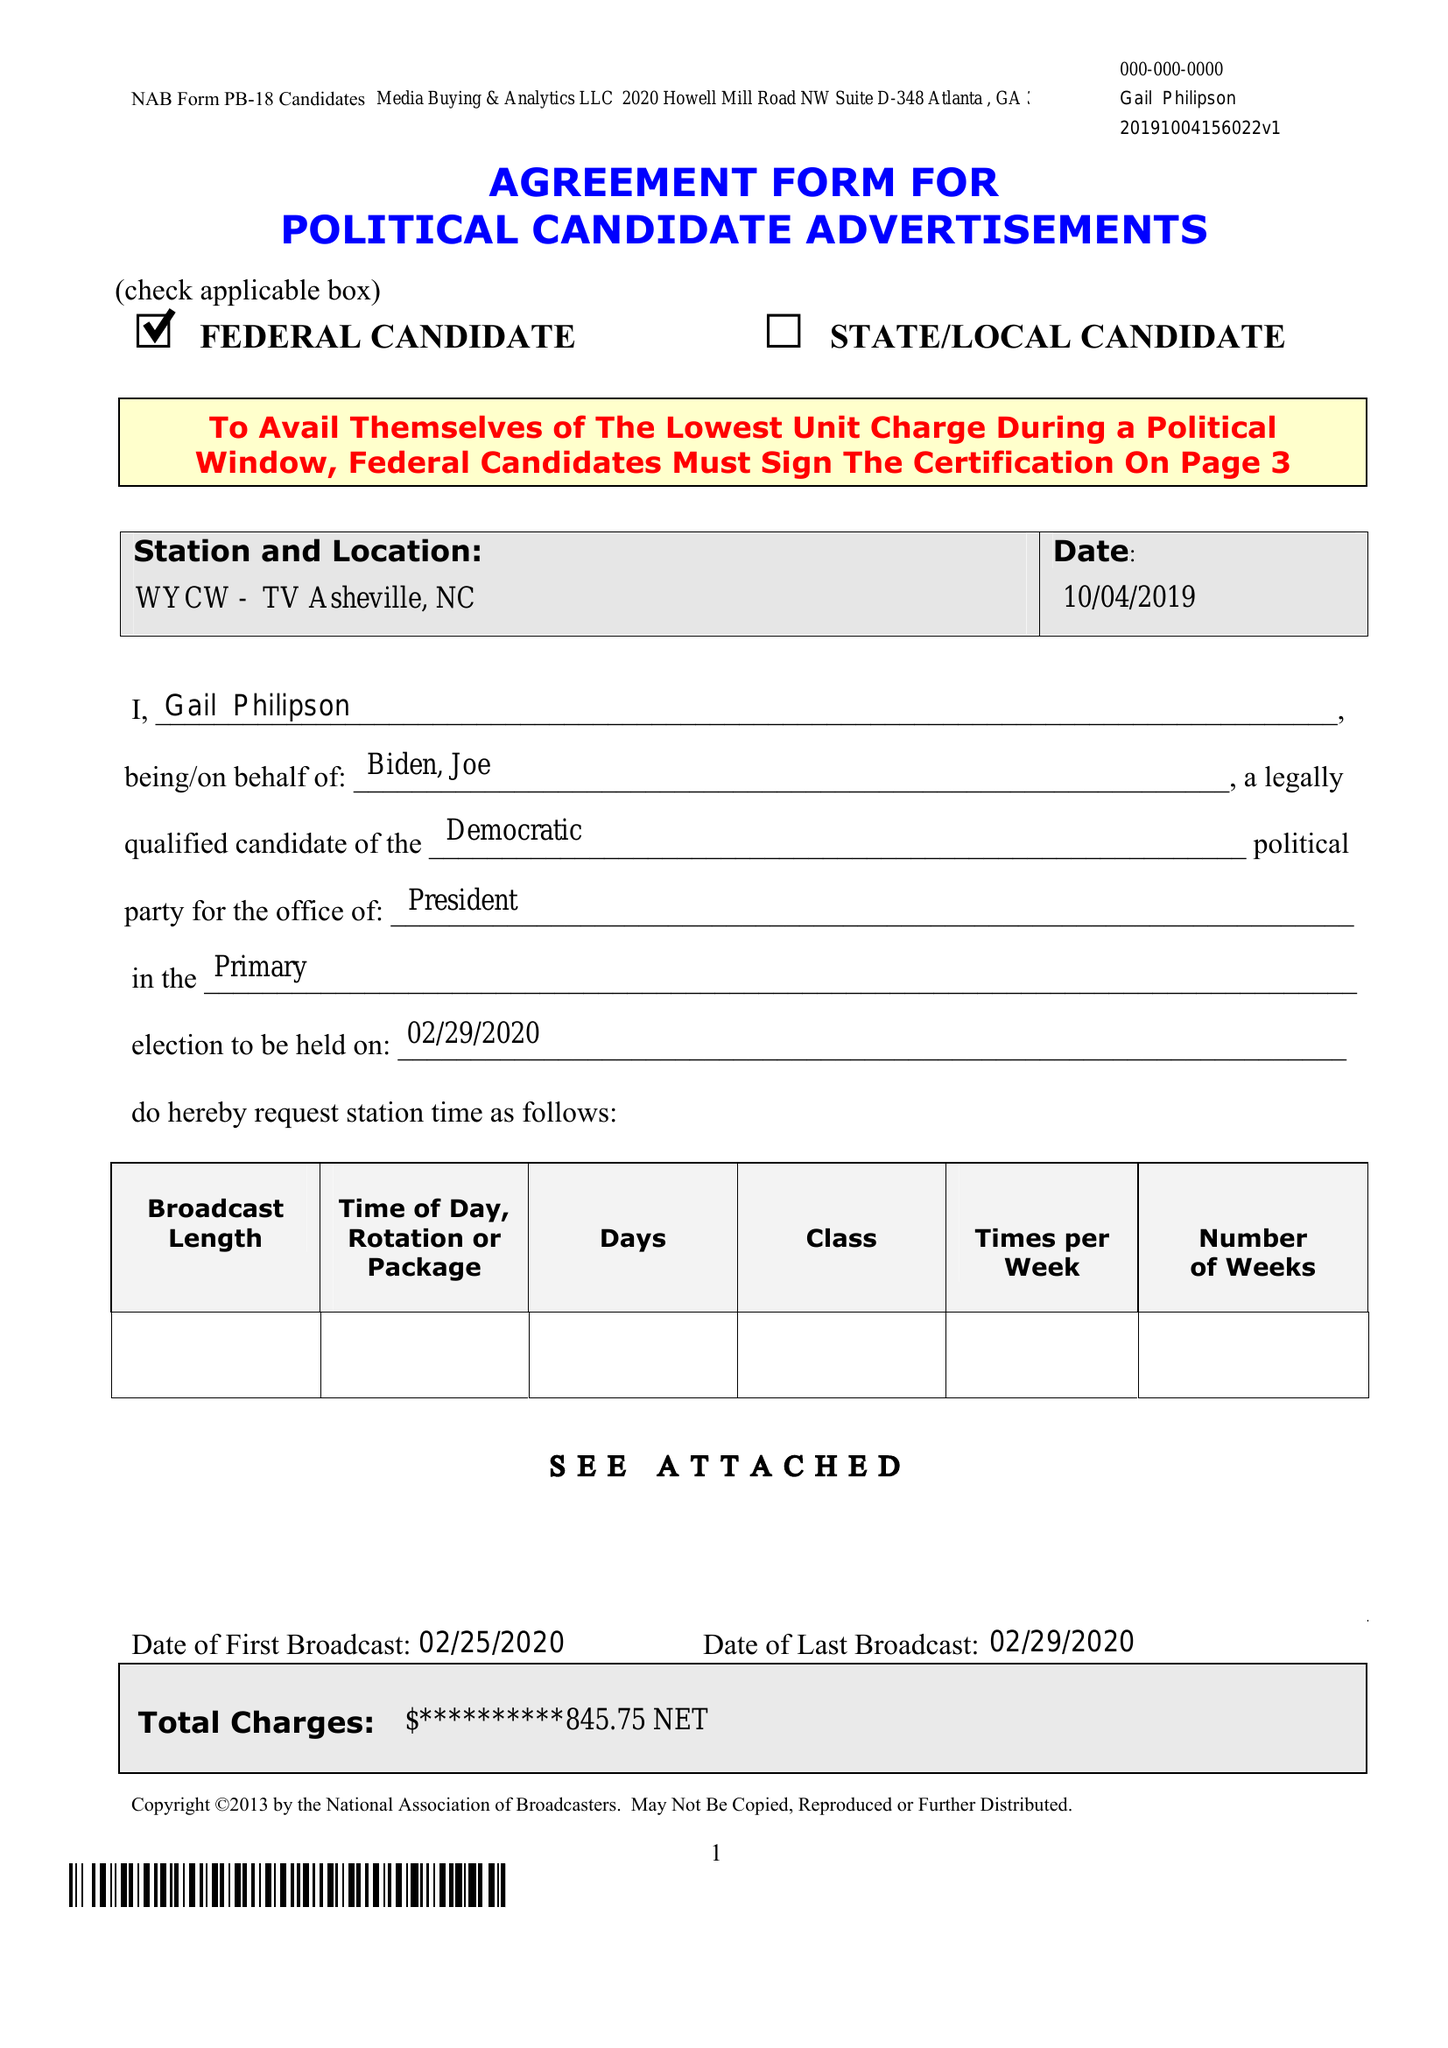What is the value for the flight_to?
Answer the question using a single word or phrase. 02/29/20 